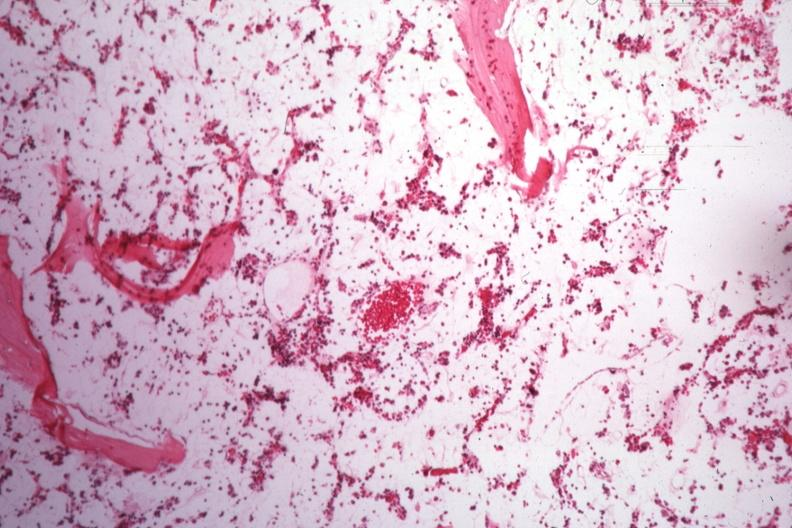what is present?
Answer the question using a single word or phrase. Bone marrow 